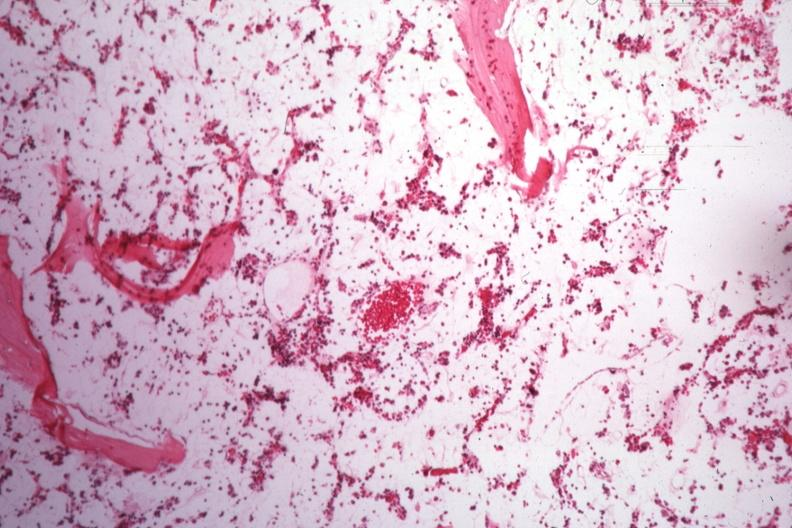what is present?
Answer the question using a single word or phrase. Bone marrow 